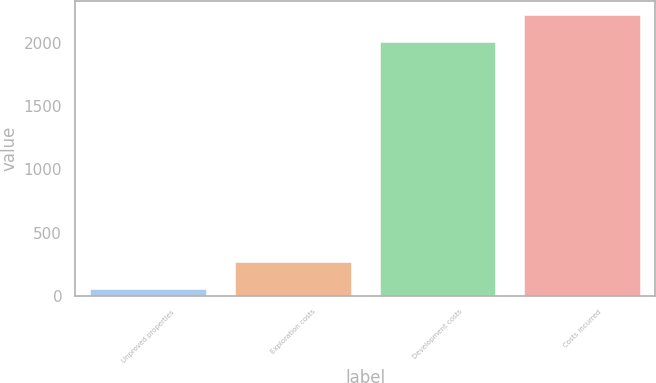Convert chart to OTSL. <chart><loc_0><loc_0><loc_500><loc_500><bar_chart><fcel>Unproved properties<fcel>Exploration costs<fcel>Development costs<fcel>Costs incurred<nl><fcel>52<fcel>267<fcel>2011<fcel>2226<nl></chart> 